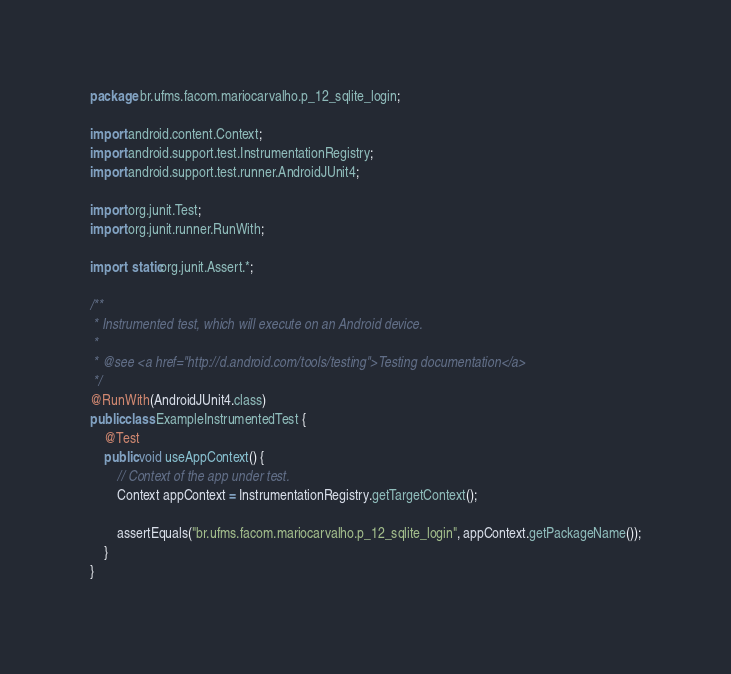<code> <loc_0><loc_0><loc_500><loc_500><_Java_>package br.ufms.facom.mariocarvalho.p_12_sqlite_login;

import android.content.Context;
import android.support.test.InstrumentationRegistry;
import android.support.test.runner.AndroidJUnit4;

import org.junit.Test;
import org.junit.runner.RunWith;

import static org.junit.Assert.*;

/**
 * Instrumented test, which will execute on an Android device.
 *
 * @see <a href="http://d.android.com/tools/testing">Testing documentation</a>
 */
@RunWith(AndroidJUnit4.class)
public class ExampleInstrumentedTest {
    @Test
    public void useAppContext() {
        // Context of the app under test.
        Context appContext = InstrumentationRegistry.getTargetContext();

        assertEquals("br.ufms.facom.mariocarvalho.p_12_sqlite_login", appContext.getPackageName());
    }
}
</code> 